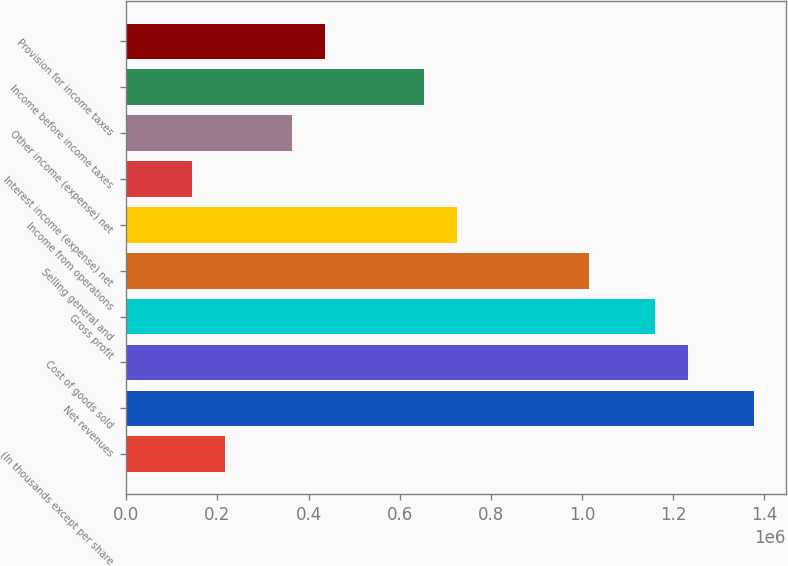Convert chart to OTSL. <chart><loc_0><loc_0><loc_500><loc_500><bar_chart><fcel>(In thousands except per share<fcel>Net revenues<fcel>Cost of goods sold<fcel>Gross profit<fcel>Selling general and<fcel>Income from operations<fcel>Interest income (expense) net<fcel>Other income (expense) net<fcel>Income before income taxes<fcel>Provision for income taxes<nl><fcel>217574<fcel>1.37796e+06<fcel>1.23291e+06<fcel>1.16039e+06<fcel>1.01534e+06<fcel>725244<fcel>145049<fcel>362622<fcel>652720<fcel>435147<nl></chart> 